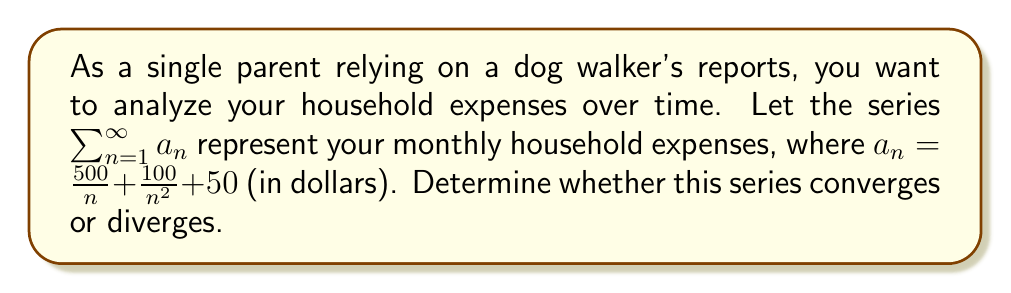Provide a solution to this math problem. To analyze the convergence of this series, we'll use the comparison test and the limit comparison test.

1) First, let's separate the series into three parts:
   $$\sum_{n=1}^{\infty} a_n = \sum_{n=1}^{\infty} (\frac{500}{n} + \frac{100}{n^2} + 50)$$
   $$= \sum_{n=1}^{\infty} \frac{500}{n} + \sum_{n=1}^{\infty} \frac{100}{n^2} + \sum_{n=1}^{\infty} 50$$

2) Analyze each part:
   a) $\sum_{n=1}^{\infty} \frac{500}{n}$: This is a constant multiple of the harmonic series, which is known to diverge.
   
   b) $\sum_{n=1}^{\infty} \frac{100}{n^2}$: This is a constant multiple of the p-series with p=2, which converges.
   
   c) $\sum_{n=1}^{\infty} 50$: This is a constant series that clearly diverges.

3) Since we have the sum of a divergent series (part a), a convergent series (part b), and another divergent series (part c), the overall series must diverge.

We can also use the limit comparison test to confirm this:

Let $b_n = \frac{1}{n}$ (the term of the harmonic series)

$$\lim_{n \to \infty} \frac{a_n}{b_n} = \lim_{n \to \infty} \frac{\frac{500}{n} + \frac{100}{n^2} + 50}{\frac{1}{n}}$$
$$= \lim_{n \to \infty} (500 + \frac{100}{n} + 50n) = \infty$$

Since this limit is infinite and $\sum b_n$ (the harmonic series) diverges, $\sum a_n$ must also diverge.
Answer: The series $\sum_{n=1}^{\infty} a_n = \sum_{n=1}^{\infty} (\frac{500}{n} + \frac{100}{n^2} + 50)$ diverges. 